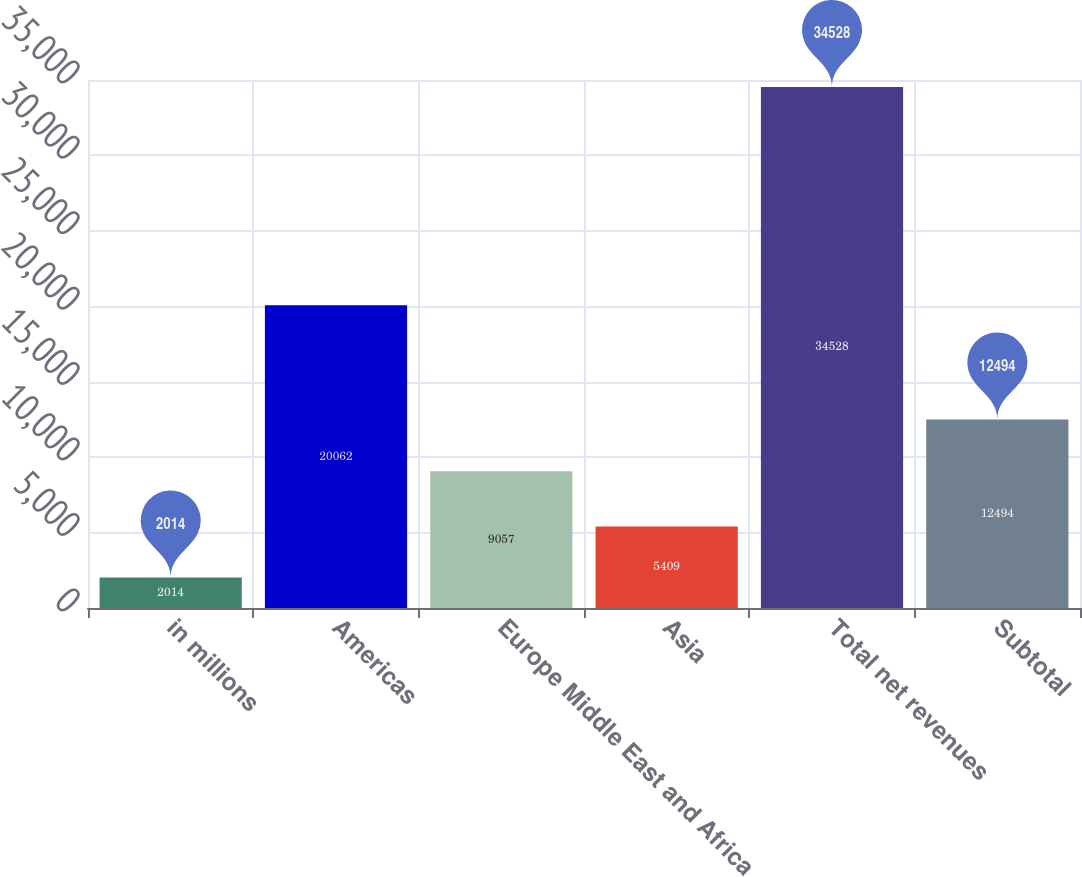<chart> <loc_0><loc_0><loc_500><loc_500><bar_chart><fcel>in millions<fcel>Americas<fcel>Europe Middle East and Africa<fcel>Asia<fcel>Total net revenues<fcel>Subtotal<nl><fcel>2014<fcel>20062<fcel>9057<fcel>5409<fcel>34528<fcel>12494<nl></chart> 